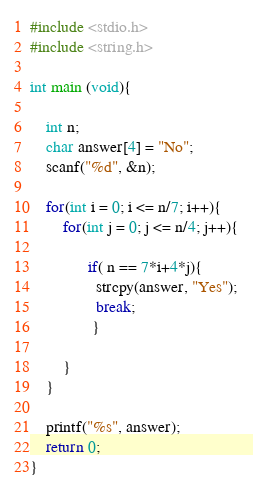Convert code to text. <code><loc_0><loc_0><loc_500><loc_500><_C_>#include <stdio.h>
#include <string.h>

int main (void){

    int n;
    char answer[4] = "No";
    scanf("%d", &n);

    for(int i = 0; i <= n/7; i++){    
        for(int j = 0; j <= n/4; j++){
  
              if( n == 7*i+4*j){
                strcpy(answer, "Yes");
                break;
               }
          
        }
    }

    printf("%s", answer);
    return 0;   
}
</code> 